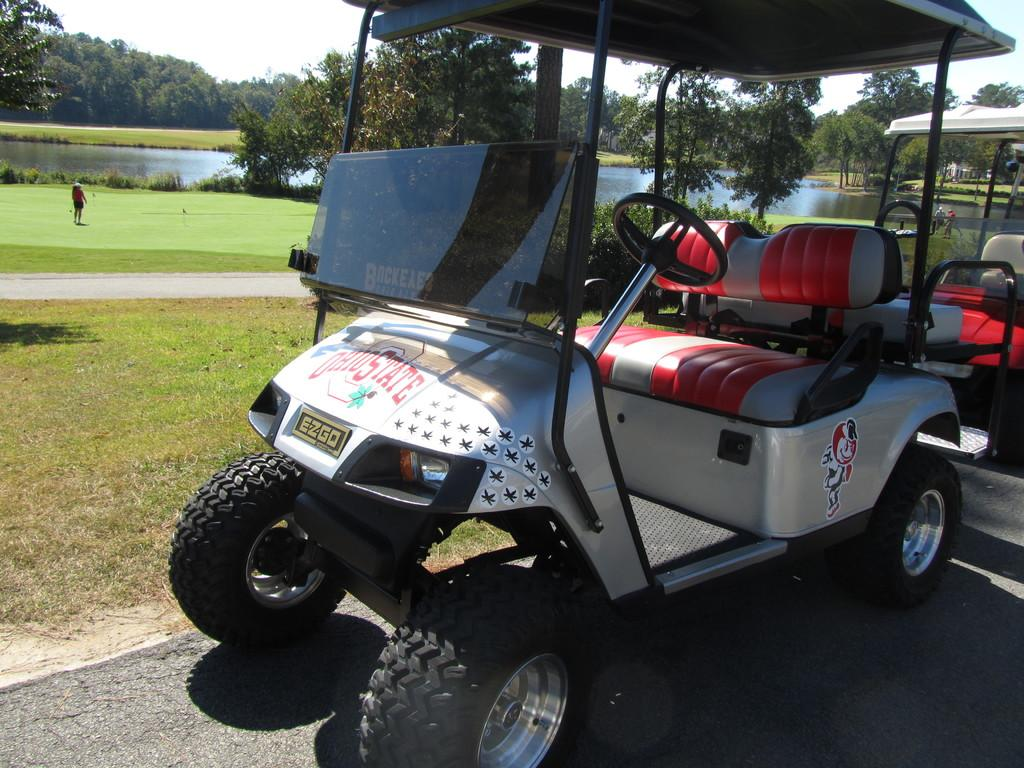What vehicle is present in the image? There is a golf cart in the image. What type of path can be seen in the image? There is a road in the image. Are there any people visible in the image? Yes, there are people in the image. What type of terrain is present in the image? There is grass in the image. What type of vegetation can be seen in the image? There are plants and trees in the image. What body of water is present in the image? There is a lake in the image. What part of the natural environment is visible in the image? The sky is visible at the top of the image. Can you describe the taste of the jellyfish in the image? There are no jellyfish present in the image, so it is not possible to describe their taste. What subject is being taught in the image? There is no indication of teaching or any educational activity in the image. 